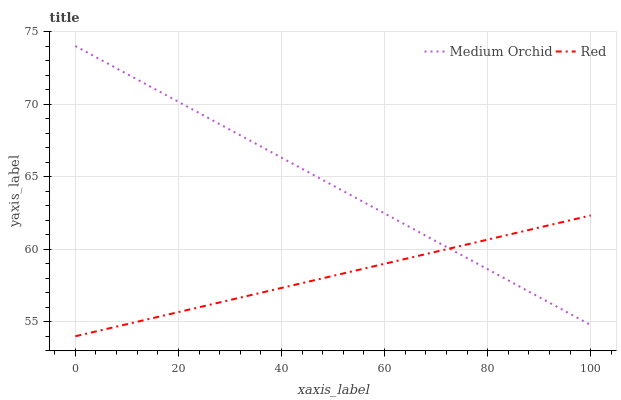Does Red have the minimum area under the curve?
Answer yes or no. Yes. Does Medium Orchid have the maximum area under the curve?
Answer yes or no. Yes. Does Red have the maximum area under the curve?
Answer yes or no. No. Is Red the smoothest?
Answer yes or no. Yes. Is Medium Orchid the roughest?
Answer yes or no. Yes. Is Red the roughest?
Answer yes or no. No. Does Red have the lowest value?
Answer yes or no. Yes. Does Medium Orchid have the highest value?
Answer yes or no. Yes. Does Red have the highest value?
Answer yes or no. No. Does Medium Orchid intersect Red?
Answer yes or no. Yes. Is Medium Orchid less than Red?
Answer yes or no. No. Is Medium Orchid greater than Red?
Answer yes or no. No. 